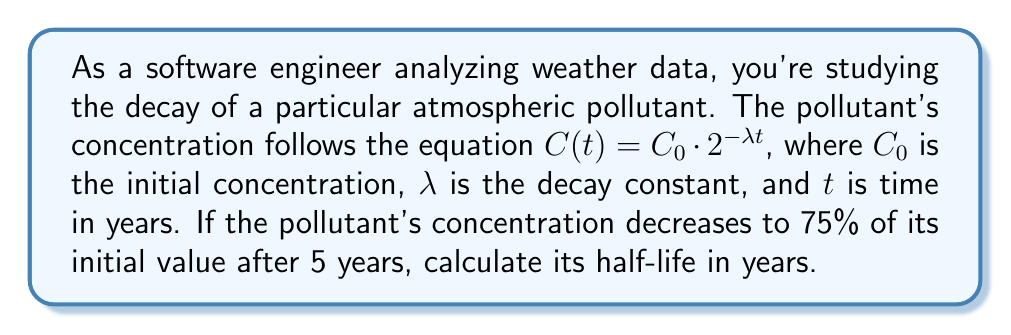Provide a solution to this math problem. Let's approach this step-by-step:

1) The half-life is the time it takes for the concentration to reduce to half its initial value. We need to find $\lambda$ first, then use it to calculate the half-life.

2) We're given that after 5 years, the concentration is 75% of the initial value. Let's use the decay equation:

   $C(5) = 0.75C_0 = C_0 \cdot 2^{-5\lambda}$

3) Dividing both sides by $C_0$:

   $0.75 = 2^{-5\lambda}$

4) Taking the logarithm (base 2) of both sides:

   $\log_2(0.75) = -5\lambda$

5) Solving for $\lambda$:

   $\lambda = -\frac{\log_2(0.75)}{5}$

6) Now, for the half-life $t_{1/2}$, we want:

   $0.5 = 2^{-\lambda t_{1/2}}$

7) Taking the logarithm (base 2) of both sides:

   $-1 = -\lambda t_{1/2}$

8) Substituting our expression for $\lambda$ and solving for $t_{1/2}$:

   $t_{1/2} = \frac{1}{\lambda} = \frac{5}{-\log_2(0.75)} \approx 13.513$ years
Answer: $13.513$ years 